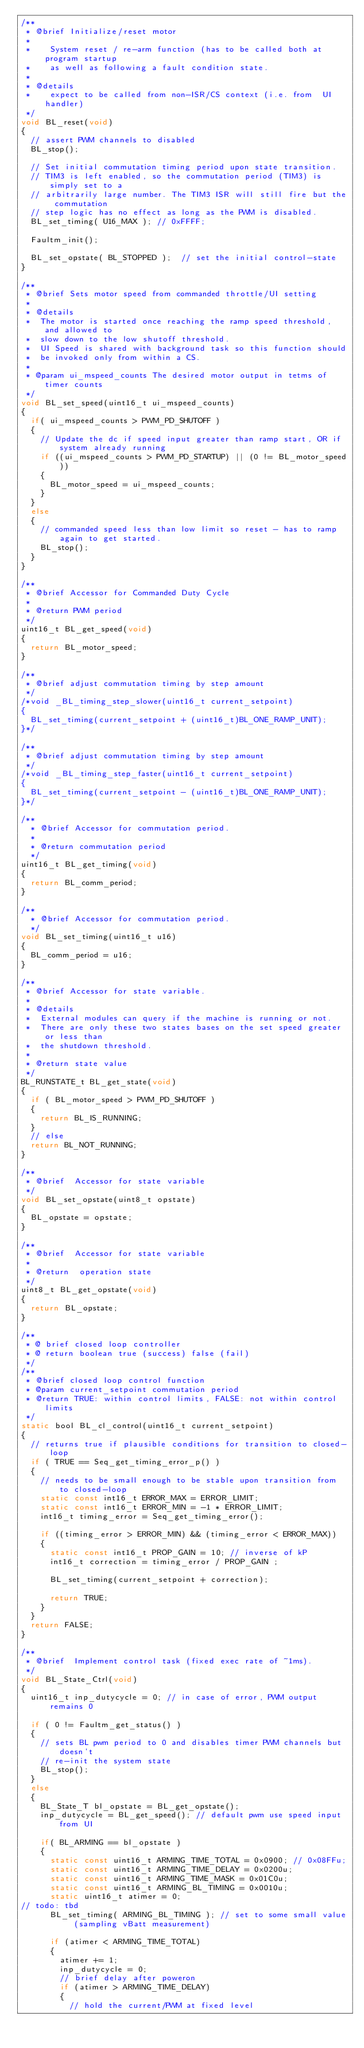Convert code to text. <code><loc_0><loc_0><loc_500><loc_500><_C_>/**
 * @brief Initialize/reset motor
 *
 *    System reset / re-arm function (has to be called both at program startup
 *    as well as following a fault condition state.
 *
 * @details
 *    expect to be called from non-ISR/CS context (i.e. from  UI handler)
 */
void BL_reset(void)
{
  // assert PWM channels to disabled
  BL_stop();

  // Set initial commutation timing period upon state transition.
  // TIM3 is left enabled, so the commutation period (TIM3) is simply set to a
  // arbitrarily large number. The TIM3 ISR will still fire but the commutation
  // step logic has no effect as long as the PWM is disabled.
  BL_set_timing( U16_MAX ); // 0xFFFF;

  Faultm_init();

  BL_set_opstate( BL_STOPPED );  // set the initial control-state
}

/**
 * @brief Sets motor speed from commanded throttle/UI setting
 *
 * @details
 *  The motor is started once reaching the ramp speed threshold, and allowed to
 *  slow down to the low shutoff threshold.
 *  UI Speed is shared with background task so this function should
 *  be invoked only from within a CS.
 *
 * @param ui_mspeed_counts The desired motor output in tetms of timer counts
 */
void BL_set_speed(uint16_t ui_mspeed_counts)
{
  if( ui_mspeed_counts > PWM_PD_SHUTOFF )
  {
    // Update the dc if speed input greater than ramp start, OR if system already running
    if ((ui_mspeed_counts > PWM_PD_STARTUP) || (0 != BL_motor_speed))
    {
      BL_motor_speed = ui_mspeed_counts;
    }
  }
  else
  {
    // commanded speed less than low limit so reset - has to ramp again to get started.
    BL_stop();
  }
}

/**
 * @brief Accessor for Commanded Duty Cycle
 *
 * @return PWM period
 */
uint16_t BL_get_speed(void)
{
  return BL_motor_speed;
}

/**
 * @brief adjust commutation timing by step amount
 */
/*void _BL_timing_step_slower(uint16_t current_setpoint)
{
  BL_set_timing(current_setpoint + (uint16_t)BL_ONE_RAMP_UNIT);
}*/

/**
 * @brief adjust commutation timing by step amount
 */
/*void _BL_timing_step_faster(uint16_t current_setpoint)
{
  BL_set_timing(current_setpoint - (uint16_t)BL_ONE_RAMP_UNIT);
}*/

/**
  * @brief Accessor for commutation period.
  *
  * @return commutation period
  */
uint16_t BL_get_timing(void)
{
  return BL_comm_period;
}

/**
  * @brief Accessor for commutation period.
  */
void BL_set_timing(uint16_t u16)
{
  BL_comm_period = u16;
}

/**
 * @brief Accessor for state variable.
 *
 * @details
 *  External modules can query if the machine is running or not.
 *  There are only these two states bases on the set speed greater or less than
 *  the shutdown threshold.
 *
 * @return state value
 */
BL_RUNSTATE_t BL_get_state(void)
{
  if ( BL_motor_speed > PWM_PD_SHUTOFF )
  {
    return BL_IS_RUNNING;
  }
  // else
  return BL_NOT_RUNNING;
}

/**
 * @brief  Accessor for state variable
 */
void BL_set_opstate(uint8_t opstate)
{
  BL_opstate = opstate;
}

/**
 * @brief  Accessor for state variable
 *
 * @return  operation state
 */
uint8_t BL_get_opstate(void)
{
  return BL_opstate;
}

/**
 * @ brief closed loop controller
 * @ return boolean true (success) false (fail)
 */
/**
 * @brief closed loop control function
 * @param current_setpoint commutation period
 * @return TRUE: within control limits, FALSE: not within control limits
 */
static bool BL_cl_control(uint16_t current_setpoint)
{
  // returns true if plausible conditions for transition to closed-loop
  if ( TRUE == Seq_get_timing_error_p() )
  {
    // needs to be small enough to be stable upon transition from to closed-loop
    static const int16_t ERROR_MAX = ERROR_LIMIT;
    static const int16_t ERROR_MIN = -1 * ERROR_LIMIT;
    int16_t timing_error = Seq_get_timing_error();

    if ((timing_error > ERROR_MIN) && (timing_error < ERROR_MAX))
    {
      static const int16_t PROP_GAIN = 10; // inverse of kP
      int16_t correction = timing_error / PROP_GAIN ;

      BL_set_timing(current_setpoint + correction);

      return TRUE;
    }
  }
  return FALSE;
}

/**
 * @brief  Implement control task (fixed exec rate of ~1ms).
 */
void BL_State_Ctrl(void)
{
  uint16_t inp_dutycycle = 0; // in case of error, PWM output remains 0

  if ( 0 != Faultm_get_status() )
  {
    // sets BL pwm period to 0 and disables timer PWM channels but doesn't
    // re-init the system state
    BL_stop();
  }
  else
  {
    BL_State_T bl_opstate = BL_get_opstate();
    inp_dutycycle = BL_get_speed(); // default pwm use speed input from UI

    if( BL_ARMING == bl_opstate )
    {
			static const uint16_t ARMING_TIME_TOTAL = 0x0900; // 0x08FFu;
			static const uint16_t ARMING_TIME_DELAY = 0x0200u;
			static const uint16_t ARMING_TIME_MASK = 0x01C0u;
			static const uint16_t ARMING_BL_TIMING = 0x0010u;
      static uint16_t atimer = 0;
// todo: tbd
      BL_set_timing( ARMING_BL_TIMING ); // set to some small value (sampling vBatt measurement)

      if (atimer < ARMING_TIME_TOTAL)
      {
        atimer += 1;
        inp_dutycycle = 0;
        // brief delay after poweron
        if (atimer > ARMING_TIME_DELAY)
        {
          // hold the current/PWM at fixed level</code> 